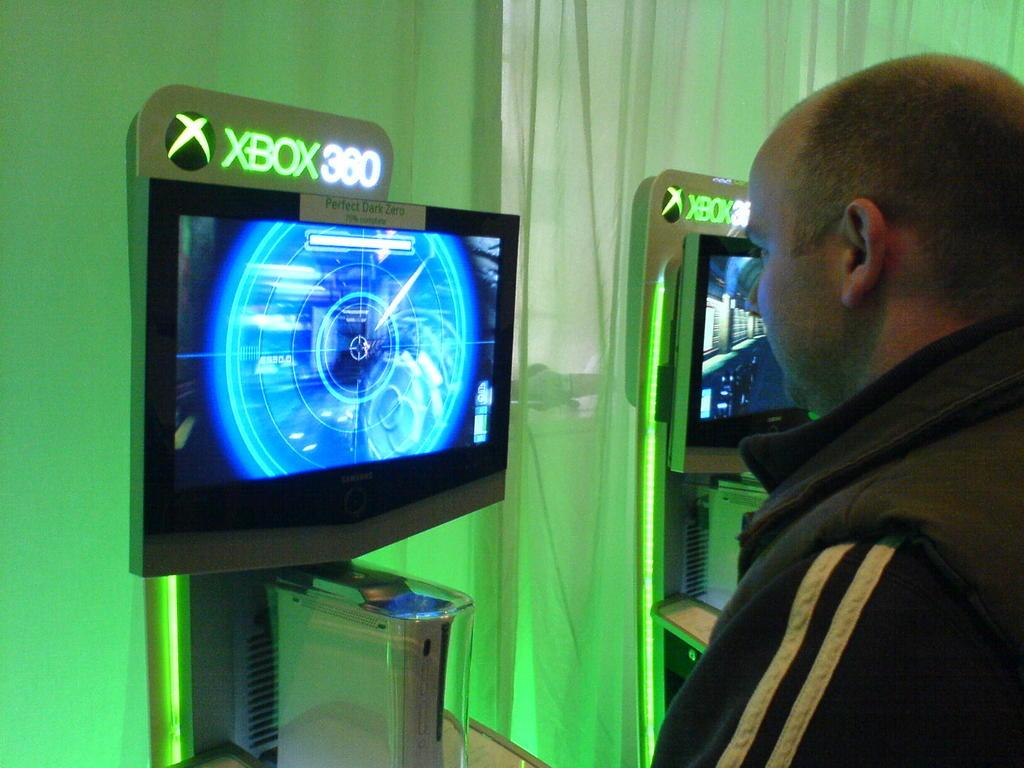<image>
Relay a brief, clear account of the picture shown. A display screen for the XBOX 360 with the game Perfect Dark Zero. 